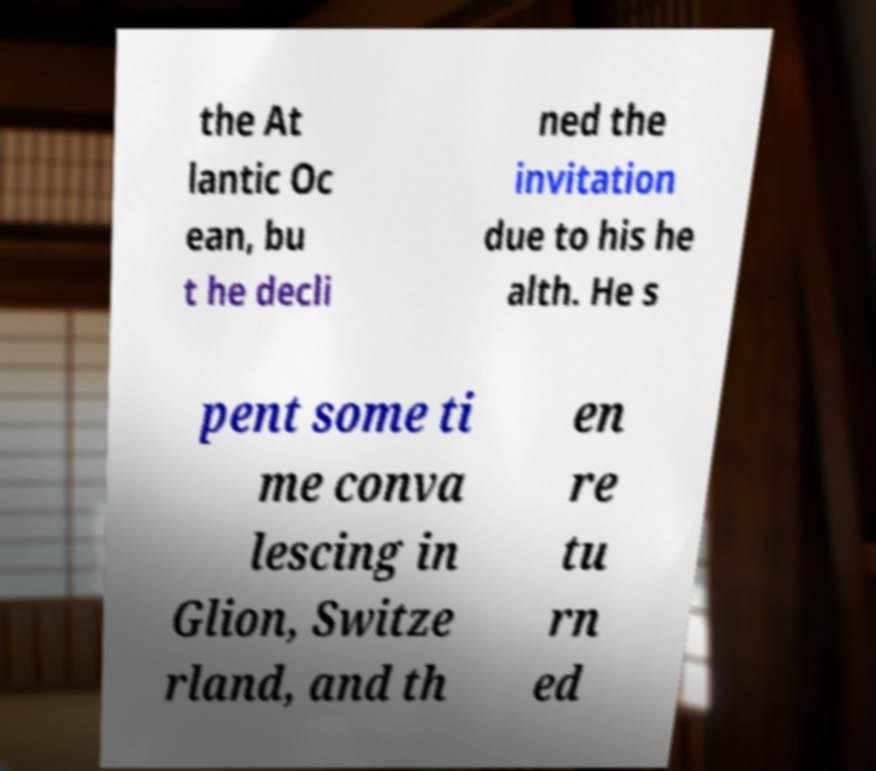Could you extract and type out the text from this image? the At lantic Oc ean, bu t he decli ned the invitation due to his he alth. He s pent some ti me conva lescing in Glion, Switze rland, and th en re tu rn ed 